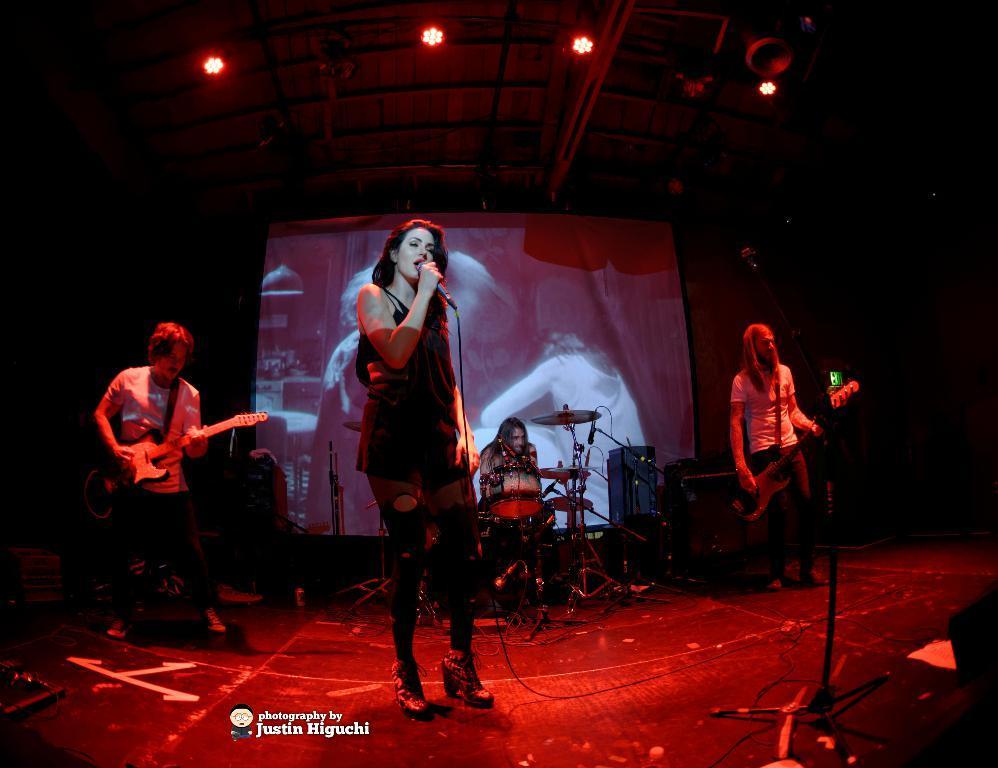Please provide a concise description of this image. In this picture there are people, among them there are two men standing and holding guitars and there is a woman holding a microphone and singing. We can see musical instrument, devices, microphone with stand and cables. In the background of the image it is dark and we can see screen. At the top of the image we can see lights. At the bottom of the image we can see logo and text. 